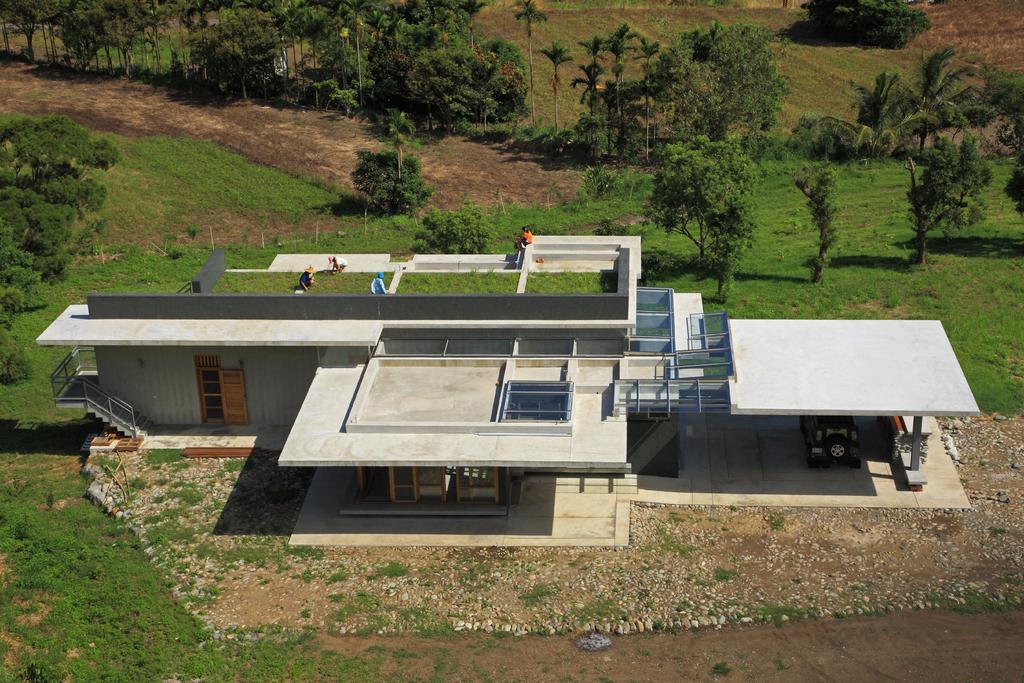Can you describe this image briefly? There is a building with doors, staircase, pillar. And there is a vehicle on the car porch of the building. In the back there are trees and plants. On top of the building there are people. 